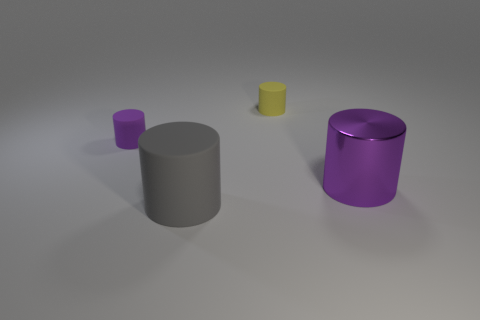Is there any other thing that has the same size as the gray rubber cylinder?
Your answer should be very brief. Yes. There is a large thing that is made of the same material as the tiny purple thing; what color is it?
Your answer should be very brief. Gray. Does the large gray object have the same material as the purple thing behind the large shiny thing?
Offer a terse response. Yes. There is a thing that is to the right of the large gray cylinder and left of the big metallic cylinder; what is its color?
Make the answer very short. Yellow. What number of cubes are either yellow things or small purple rubber things?
Keep it short and to the point. 0. Does the tiny purple thing have the same shape as the large thing behind the big rubber object?
Make the answer very short. Yes. What is the size of the object that is both to the right of the large gray rubber cylinder and in front of the yellow rubber cylinder?
Your response must be concise. Large. The gray matte object has what shape?
Offer a very short reply. Cylinder. Is there a purple thing in front of the tiny cylinder left of the gray matte object?
Your answer should be compact. Yes. There is a tiny object that is behind the tiny purple thing; what number of purple shiny cylinders are on the right side of it?
Provide a succinct answer. 1. 